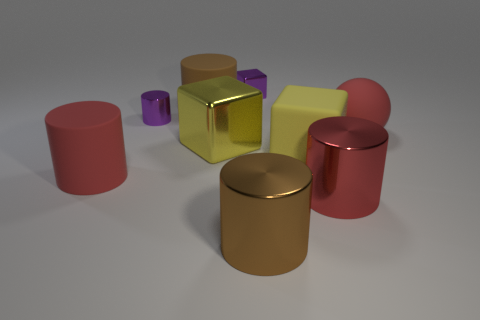There is a small metal object that is to the right of the yellow shiny block; is its color the same as the ball? No, the small metal object to the right of the yellow shiny block is silver in color, which contrasts with the red color of the ball. 